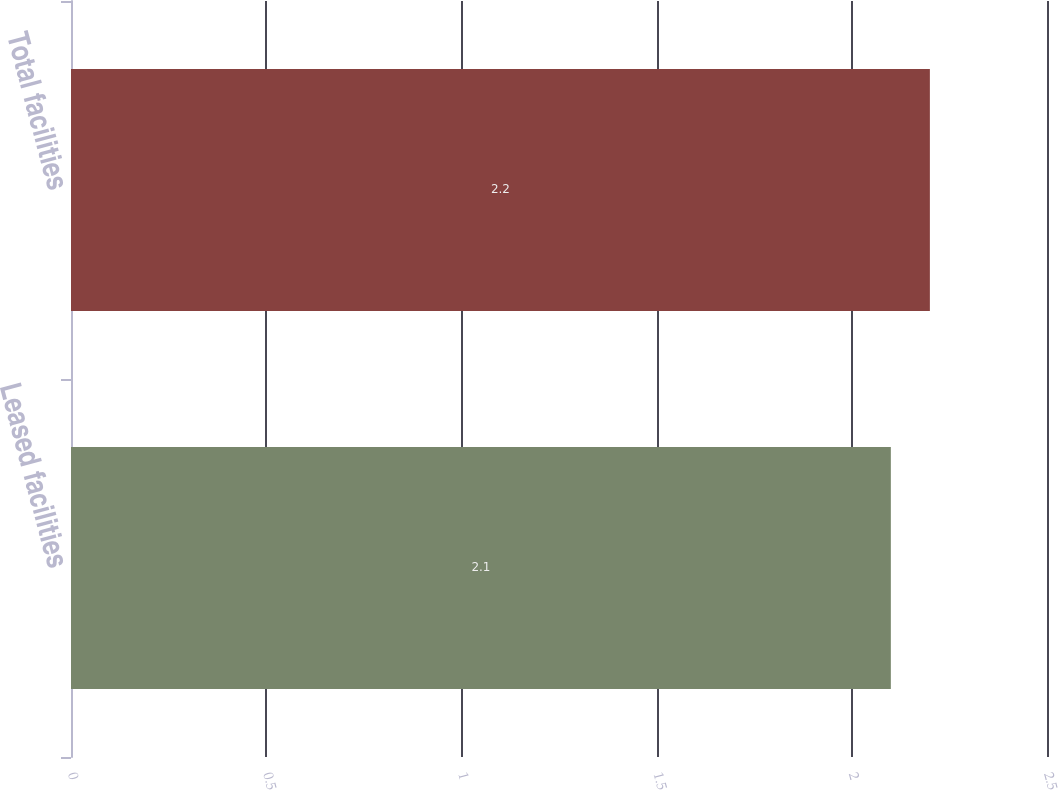<chart> <loc_0><loc_0><loc_500><loc_500><bar_chart><fcel>Leased facilities<fcel>Total facilities<nl><fcel>2.1<fcel>2.2<nl></chart> 